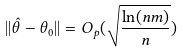<formula> <loc_0><loc_0><loc_500><loc_500>| | \hat { \theta } - \theta _ { 0 } | | = O _ { p } ( \sqrt { \frac { \ln ( n m ) } { n } } )</formula> 